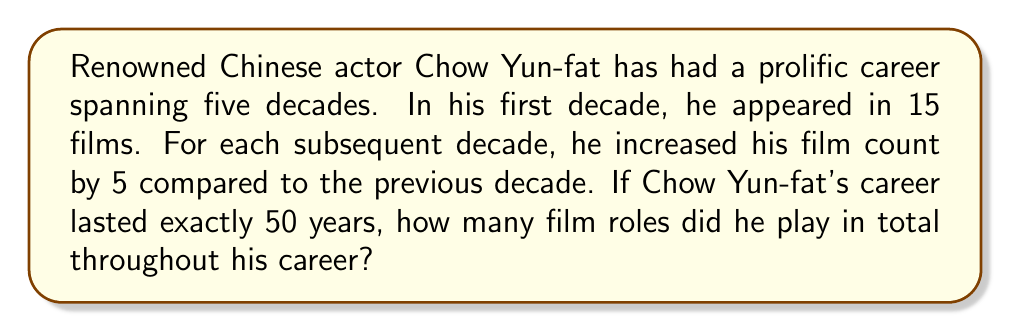Solve this math problem. Let's approach this problem step-by-step:

1) First, we need to calculate the number of films for each decade:

   Decade 1: 15 films
   Decade 2: 15 + 5 = 20 films
   Decade 3: 20 + 5 = 25 films
   Decade 4: 25 + 5 = 30 films
   Decade 5: 30 + 5 = 35 films

2) Now, we need to sum up the number of films from all five decades:

   $$ \text{Total films} = 15 + 20 + 25 + 30 + 35 $$

3) This is an arithmetic sequence with 5 terms. We can use the formula for the sum of an arithmetic sequence:

   $$ S_n = \frac{n}{2}(a_1 + a_n) $$

   Where:
   $S_n$ is the sum of the sequence
   $n$ is the number of terms (5 in this case)
   $a_1$ is the first term (15)
   $a_n$ is the last term (35)

4) Plugging in our values:

   $$ S_5 = \frac{5}{2}(15 + 35) = \frac{5}{2}(50) = 125 $$

Therefore, Chow Yun-fat played roles in 125 films throughout his 50-year career.
Answer: 125 film roles 